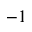Convert formula to latex. <formula><loc_0><loc_0><loc_500><loc_500>^ { - 1 }</formula> 